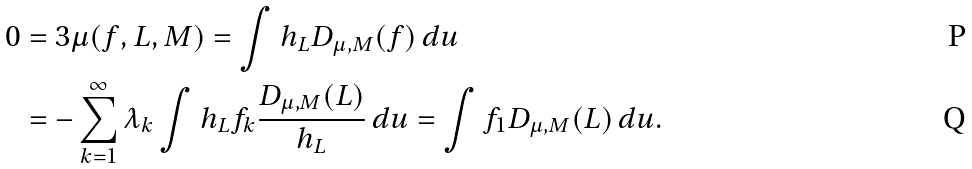<formula> <loc_0><loc_0><loc_500><loc_500>0 & = 3 \mu ( f , L , M ) = \int h _ { L } D _ { \mu , M } ( f ) \, d u \\ & = - \sum _ { k = 1 } ^ { \infty } \lambda _ { k } \int h _ { L } f _ { k } \frac { D _ { \mu , M } ( L ) } { h _ { L } } \, d u = \int f _ { 1 } D _ { \mu , M } ( L ) \, d u .</formula> 